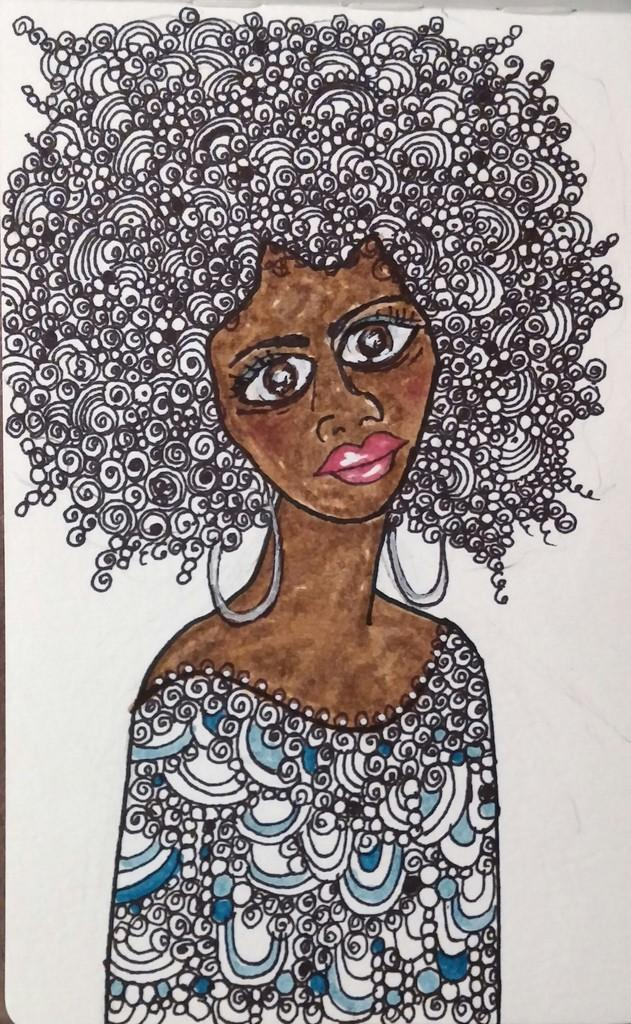What is depicted on the paper in the image? The paper contains a drawing of a woman. Can you describe the drawing in more detail? Unfortunately, the facts provided do not give any additional details about the drawing. Is there anything else present in the image besides the paper? The facts provided do not mention any other objects or subjects in the image. What type of crate is being used to store the chair in the image? There is no crate or chair present in the image; it only contains a paper with a drawing of a woman. 